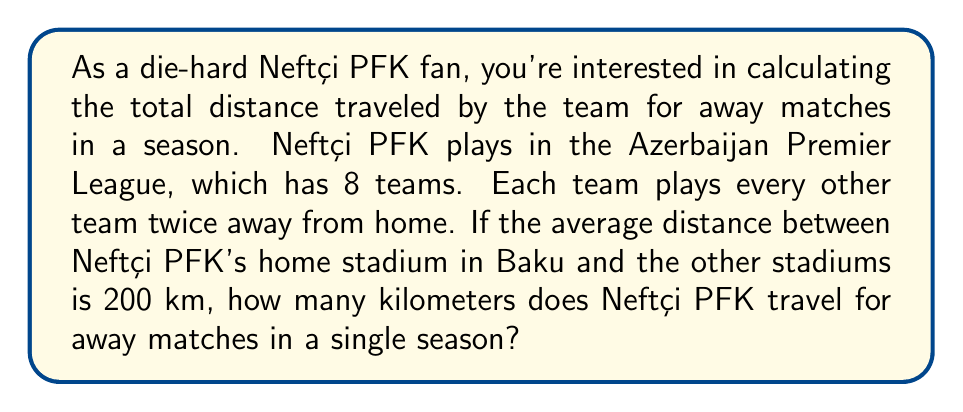Solve this math problem. Let's break this problem down step-by-step:

1. First, we need to calculate how many away matches Neftçi PFK plays in a season.
   - There are 8 teams in the league.
   - Neftçi PFK plays against each other team twice away from home.
   - Number of away matches = $(8 - 1) \times 2 = 7 \times 2 = 14$

2. Now we know that Neftçi PFK plays 14 away matches in a season.

3. The average distance to each away stadium is 200 km.

4. For each away match, the team travels to the away stadium and back. So we need to double the distance.
   Distance per away match = $200 \times 2 = 400$ km

5. To find the total distance traveled, we multiply the number of away matches by the distance per away match:

   $$\text{Total distance} = \text{Number of away matches} \times \text{Distance per away match}$$
   $$\text{Total distance} = 14 \times 400 = 5600 \text{ km}$$

Therefore, Neftçi PFK travels 5600 km for away matches in a single season.
Answer: 5600 km 